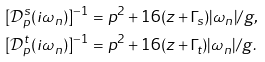<formula> <loc_0><loc_0><loc_500><loc_500>[ \mathcal { D } ^ { s } _ { p } ( i \omega _ { n } ) ] ^ { - 1 } & = p ^ { 2 } + { 1 6 ( z + \Gamma _ { s } ) | \omega _ { n } | } / { g } , \\ [ \mathcal { D } ^ { t } _ { p } ( i \omega _ { n } ) ] ^ { - 1 } & = p ^ { 2 } + { 1 6 ( z + \Gamma _ { t } ) | \omega _ { n } | } / { g } .</formula> 